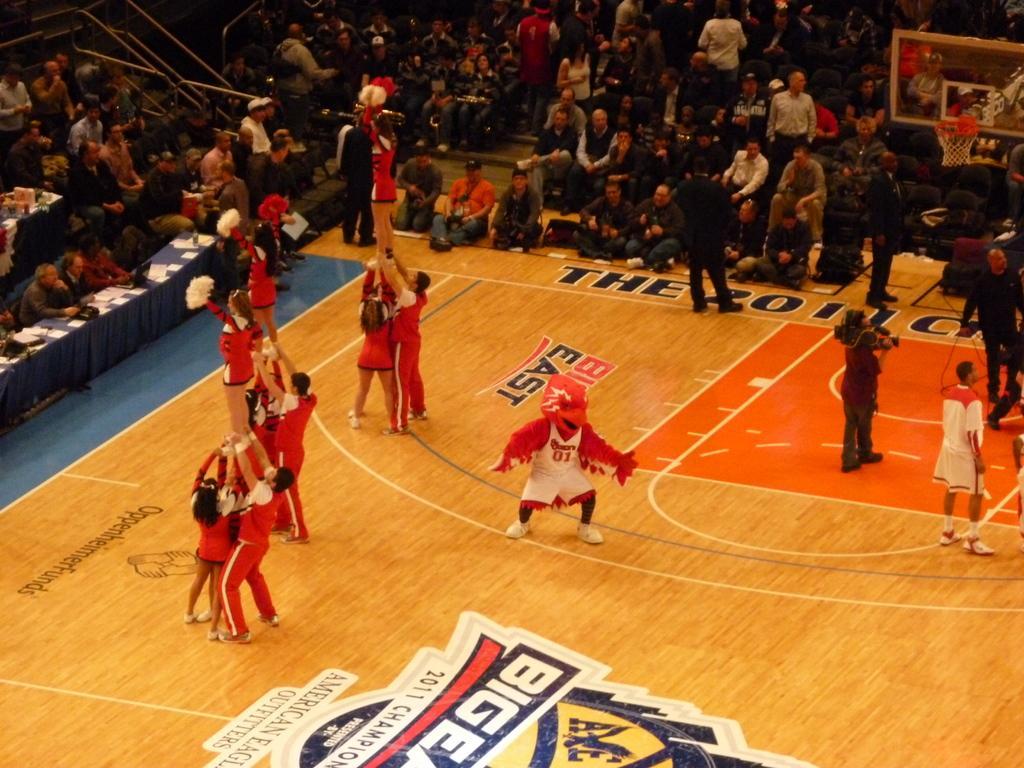Can you describe this image briefly? There are few persons on the floor. Here we can see tables, cloth, and papers. There is a basketball goal. In the background there is crowd. 